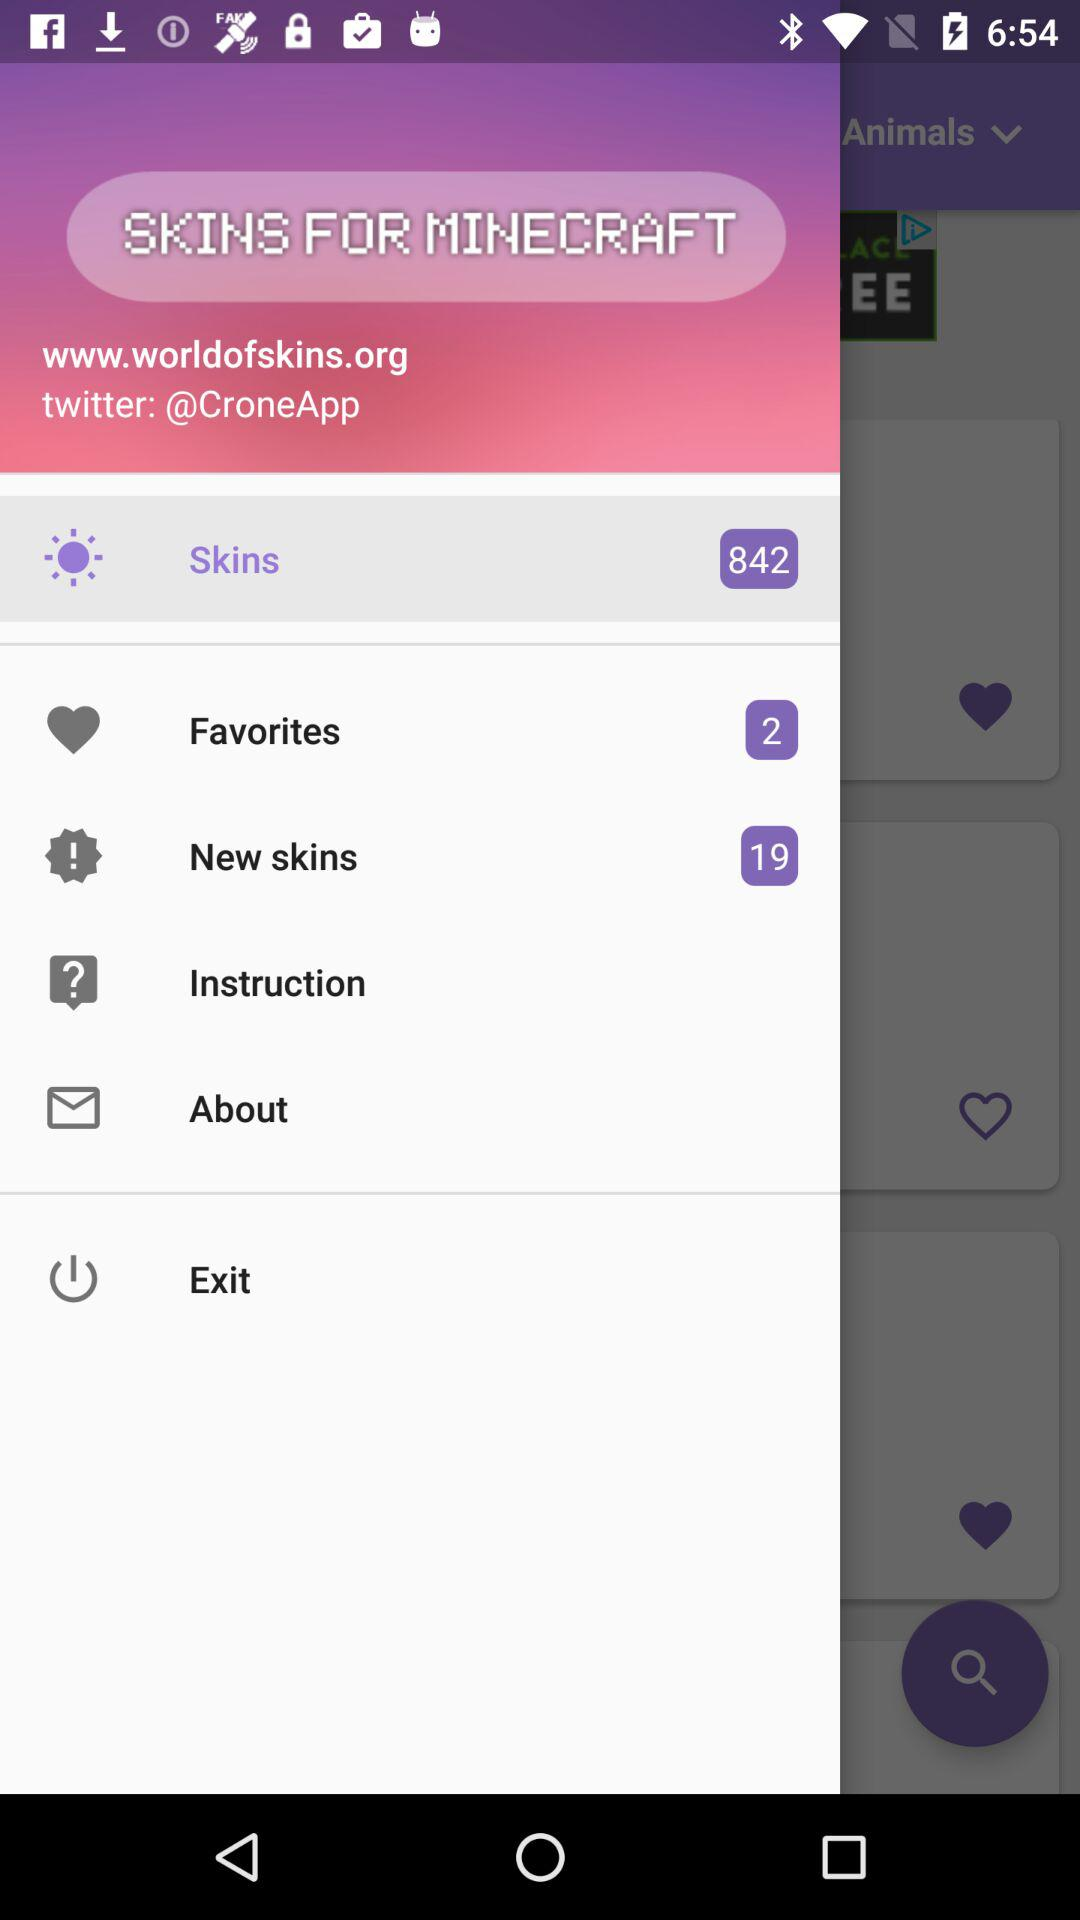How many items are there in "Favorites"? There are 2 items in "Favorites". 